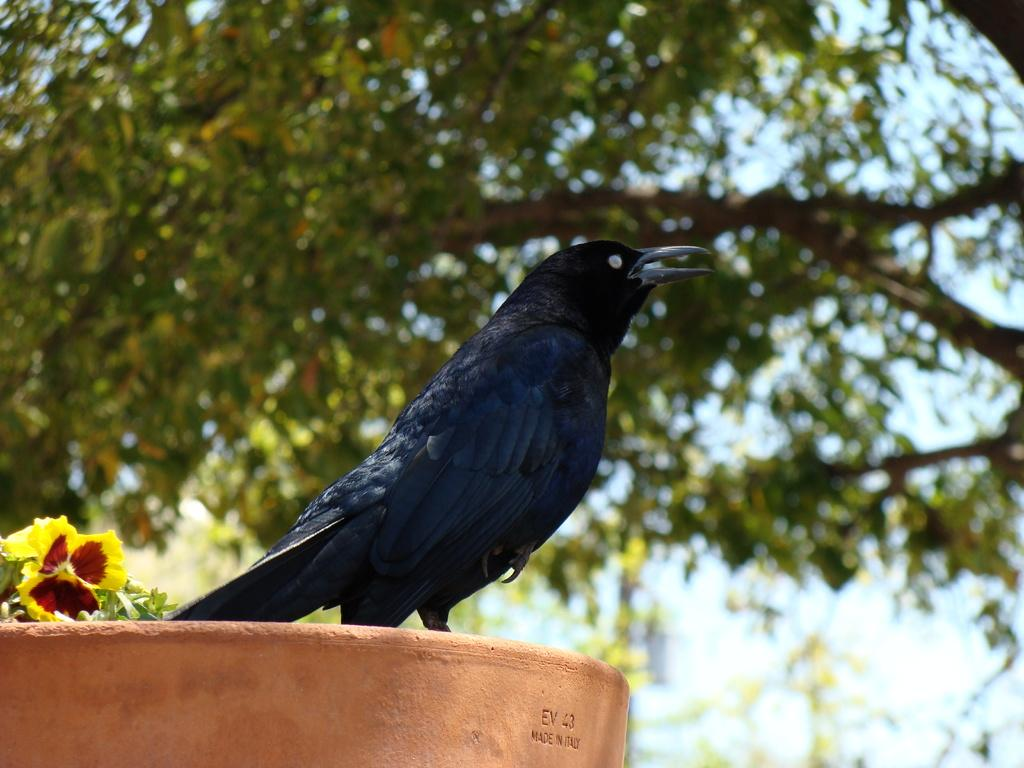What type of bird is in the image? There is a crow in the image. What can be seen on the left side of the image? There is a flower on the left side of the image. What is visible in the background of the image? There are trees in the background of the image. What is at the bottom of the image? There appears to be a wall at the bottom of the image. How does the son interact with the crow in the image? There is no son present in the image, so there is no interaction between a son and the crow. 